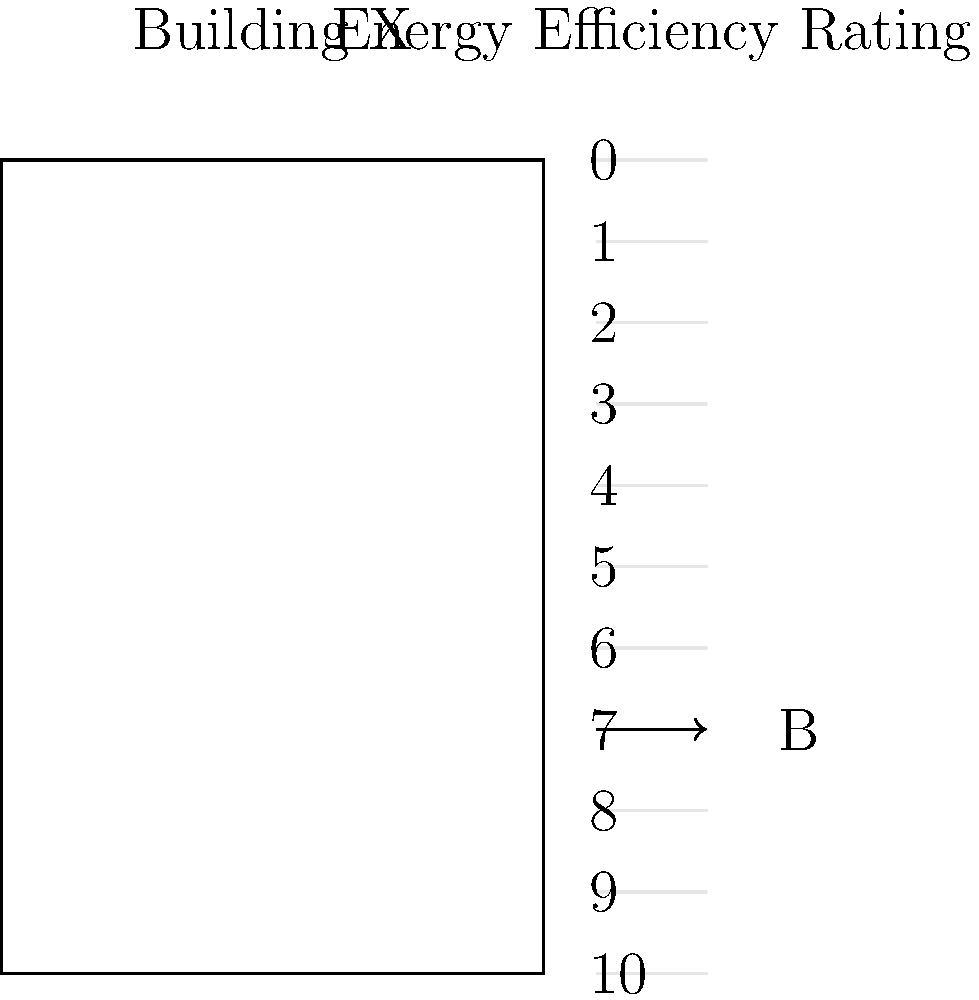Based on the energy efficiency diagram for Building X, what is its rating on a scale of 1 to 10, where 10 is the most efficient? How might this rating influence your assessment of the building's environmental impact? To interpret the energy efficiency rating:

1. Observe the scale on the right side of the diagram, ranging from 0 to 10.
2. Note that the scale is inverted, with 10 at the bottom and 0 at the top.
3. Locate the arrow pointing to the building's rating, which is marked with a "B".
4. The arrow points to a position between 6 and 7 on the inverted scale.
5. Since 10 is the most efficient, we need to convert this to the 1-10 scale.
6. The building's rating is approximately at position 7 on the inverted scale.
7. To convert to the 1-10 scale, subtract 7 from 10: $10 - 7 = 3$.

Therefore, the building's energy efficiency rating is approximately 3 out of 10.

This rating would significantly influence the assessment of the building's environmental impact:

1. A low rating of 3/10 indicates poor energy efficiency.
2. This suggests high energy consumption and potentially higher greenhouse gas emissions.
3. It may indicate inadequate insulation, outdated HVAC systems, or inefficient lighting.
4. The building likely has a larger carbon footprint compared to more efficient structures.
5. This rating would negatively impact the overall sustainability assessment of the real estate project.
6. It would likely lead to recommendations for energy efficiency improvements or retrofitting.
7. The low rating might also affect the building's market value and operational costs.
Answer: 3 out of 10; indicates poor energy efficiency, suggesting high environmental impact and need for improvements. 